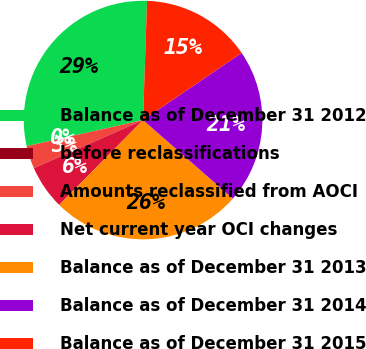Convert chart. <chart><loc_0><loc_0><loc_500><loc_500><pie_chart><fcel>Balance as of December 31 2012<fcel>before reclassifications<fcel>Amounts reclassified from AOCI<fcel>Net current year OCI changes<fcel>Balance as of December 31 2013<fcel>Balance as of December 31 2014<fcel>Balance as of December 31 2015<nl><fcel>29.05%<fcel>0.0%<fcel>3.09%<fcel>5.99%<fcel>25.97%<fcel>20.96%<fcel>14.95%<nl></chart> 